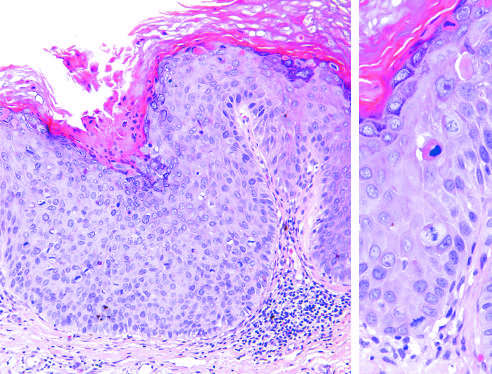does the wall of the gallbladder show several mitotic figures, some above the basal layer, and nuclear pleomorphism?
Answer the question using a single word or phrase. No 